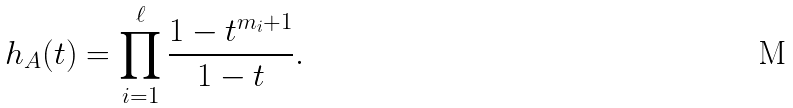<formula> <loc_0><loc_0><loc_500><loc_500>h _ { A } ( t ) = \prod _ { i = 1 } ^ { \ell } \frac { 1 - t ^ { m _ { i } + 1 } } { 1 - t } .</formula> 